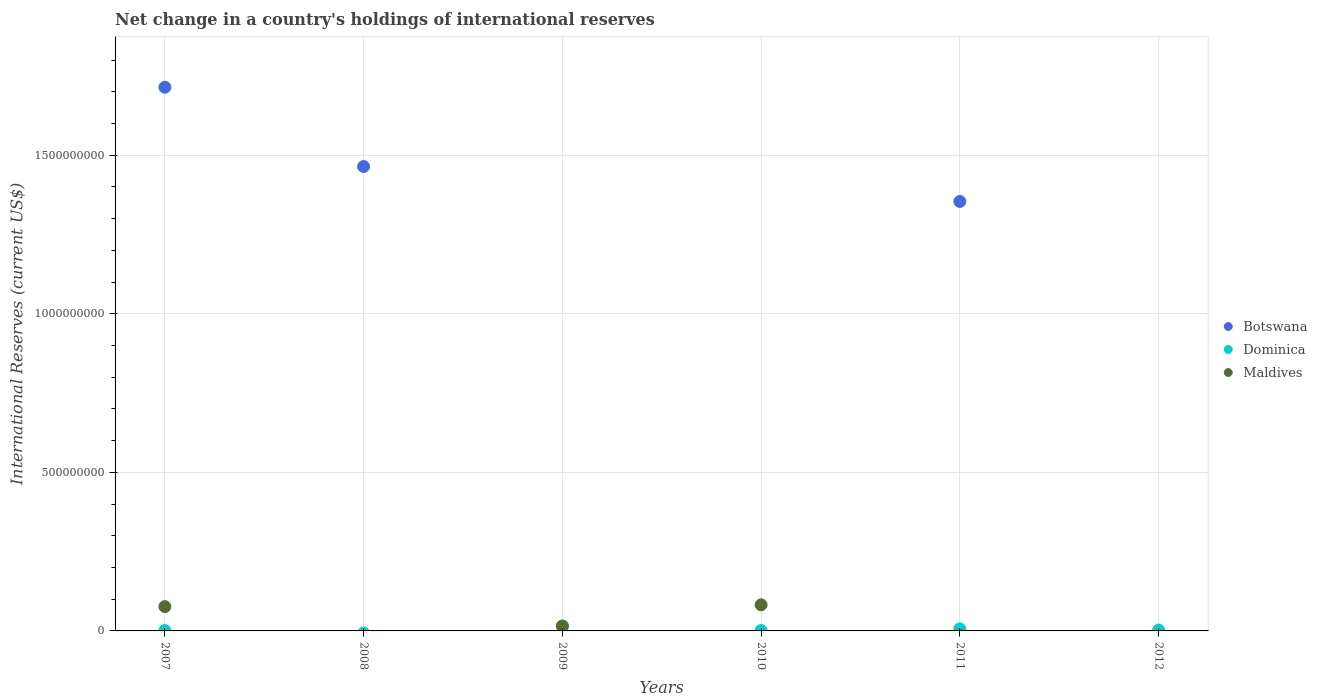How many different coloured dotlines are there?
Offer a very short reply. 3. Is the number of dotlines equal to the number of legend labels?
Give a very brief answer. No. Across all years, what is the maximum international reserves in Botswana?
Offer a very short reply. 1.71e+09. In which year was the international reserves in Botswana maximum?
Your answer should be compact. 2007. What is the total international reserves in Botswana in the graph?
Make the answer very short. 4.53e+09. What is the difference between the international reserves in Dominica in 2009 and that in 2012?
Offer a terse response. 1.26e+07. What is the difference between the international reserves in Dominica in 2007 and the international reserves in Botswana in 2009?
Your response must be concise. 1.16e+06. What is the average international reserves in Botswana per year?
Provide a succinct answer. 7.56e+08. In the year 2010, what is the difference between the international reserves in Dominica and international reserves in Maldives?
Ensure brevity in your answer.  -8.11e+07. What is the ratio of the international reserves in Dominica in 2010 to that in 2011?
Provide a short and direct response. 0.19. Is the international reserves in Botswana in 2007 less than that in 2008?
Provide a short and direct response. No. Is the difference between the international reserves in Dominica in 2009 and 2010 greater than the difference between the international reserves in Maldives in 2009 and 2010?
Provide a short and direct response. Yes. What is the difference between the highest and the second highest international reserves in Botswana?
Provide a short and direct response. 2.50e+08. What is the difference between the highest and the lowest international reserves in Maldives?
Provide a short and direct response. 8.23e+07. In how many years, is the international reserves in Maldives greater than the average international reserves in Maldives taken over all years?
Provide a short and direct response. 2. Is the sum of the international reserves in Dominica in 2007 and 2009 greater than the maximum international reserves in Maldives across all years?
Offer a terse response. No. Is the international reserves in Dominica strictly less than the international reserves in Maldives over the years?
Give a very brief answer. No. How many years are there in the graph?
Ensure brevity in your answer.  6. Does the graph contain grids?
Keep it short and to the point. Yes. How many legend labels are there?
Make the answer very short. 3. How are the legend labels stacked?
Make the answer very short. Vertical. What is the title of the graph?
Keep it short and to the point. Net change in a country's holdings of international reserves. What is the label or title of the X-axis?
Ensure brevity in your answer.  Years. What is the label or title of the Y-axis?
Your answer should be very brief. International Reserves (current US$). What is the International Reserves (current US$) of Botswana in 2007?
Provide a short and direct response. 1.71e+09. What is the International Reserves (current US$) of Dominica in 2007?
Provide a short and direct response. 1.16e+06. What is the International Reserves (current US$) of Maldives in 2007?
Offer a very short reply. 7.67e+07. What is the International Reserves (current US$) in Botswana in 2008?
Your answer should be very brief. 1.46e+09. What is the International Reserves (current US$) of Dominica in 2008?
Offer a terse response. 0. What is the International Reserves (current US$) in Maldives in 2008?
Your answer should be compact. 0. What is the International Reserves (current US$) of Dominica in 2009?
Give a very brief answer. 1.53e+07. What is the International Reserves (current US$) of Maldives in 2009?
Your answer should be very brief. 1.54e+07. What is the International Reserves (current US$) of Botswana in 2010?
Make the answer very short. 0. What is the International Reserves (current US$) in Dominica in 2010?
Give a very brief answer. 1.24e+06. What is the International Reserves (current US$) in Maldives in 2010?
Give a very brief answer. 8.23e+07. What is the International Reserves (current US$) of Botswana in 2011?
Your response must be concise. 1.35e+09. What is the International Reserves (current US$) in Dominica in 2011?
Provide a short and direct response. 6.48e+06. What is the International Reserves (current US$) in Botswana in 2012?
Your response must be concise. 0. What is the International Reserves (current US$) of Dominica in 2012?
Offer a very short reply. 2.73e+06. What is the International Reserves (current US$) in Maldives in 2012?
Provide a succinct answer. 0. Across all years, what is the maximum International Reserves (current US$) of Botswana?
Keep it short and to the point. 1.71e+09. Across all years, what is the maximum International Reserves (current US$) in Dominica?
Provide a short and direct response. 1.53e+07. Across all years, what is the maximum International Reserves (current US$) of Maldives?
Your answer should be very brief. 8.23e+07. Across all years, what is the minimum International Reserves (current US$) in Dominica?
Ensure brevity in your answer.  0. What is the total International Reserves (current US$) in Botswana in the graph?
Provide a short and direct response. 4.53e+09. What is the total International Reserves (current US$) in Dominica in the graph?
Provide a succinct answer. 2.69e+07. What is the total International Reserves (current US$) of Maldives in the graph?
Ensure brevity in your answer.  1.74e+08. What is the difference between the International Reserves (current US$) in Botswana in 2007 and that in 2008?
Your answer should be very brief. 2.50e+08. What is the difference between the International Reserves (current US$) in Dominica in 2007 and that in 2009?
Offer a very short reply. -1.42e+07. What is the difference between the International Reserves (current US$) in Maldives in 2007 and that in 2009?
Offer a terse response. 6.13e+07. What is the difference between the International Reserves (current US$) of Dominica in 2007 and that in 2010?
Provide a succinct answer. -7.75e+04. What is the difference between the International Reserves (current US$) of Maldives in 2007 and that in 2010?
Your response must be concise. -5.64e+06. What is the difference between the International Reserves (current US$) in Botswana in 2007 and that in 2011?
Your response must be concise. 3.60e+08. What is the difference between the International Reserves (current US$) in Dominica in 2007 and that in 2011?
Your answer should be very brief. -5.32e+06. What is the difference between the International Reserves (current US$) in Dominica in 2007 and that in 2012?
Ensure brevity in your answer.  -1.57e+06. What is the difference between the International Reserves (current US$) in Botswana in 2008 and that in 2011?
Your answer should be compact. 1.10e+08. What is the difference between the International Reserves (current US$) of Dominica in 2009 and that in 2010?
Give a very brief answer. 1.41e+07. What is the difference between the International Reserves (current US$) in Maldives in 2009 and that in 2010?
Provide a short and direct response. -6.70e+07. What is the difference between the International Reserves (current US$) of Dominica in 2009 and that in 2011?
Your answer should be very brief. 8.84e+06. What is the difference between the International Reserves (current US$) in Dominica in 2009 and that in 2012?
Give a very brief answer. 1.26e+07. What is the difference between the International Reserves (current US$) in Dominica in 2010 and that in 2011?
Make the answer very short. -5.24e+06. What is the difference between the International Reserves (current US$) in Dominica in 2010 and that in 2012?
Your response must be concise. -1.49e+06. What is the difference between the International Reserves (current US$) in Dominica in 2011 and that in 2012?
Offer a terse response. 3.75e+06. What is the difference between the International Reserves (current US$) of Botswana in 2007 and the International Reserves (current US$) of Dominica in 2009?
Give a very brief answer. 1.70e+09. What is the difference between the International Reserves (current US$) in Botswana in 2007 and the International Reserves (current US$) in Maldives in 2009?
Ensure brevity in your answer.  1.70e+09. What is the difference between the International Reserves (current US$) in Dominica in 2007 and the International Reserves (current US$) in Maldives in 2009?
Keep it short and to the point. -1.42e+07. What is the difference between the International Reserves (current US$) of Botswana in 2007 and the International Reserves (current US$) of Dominica in 2010?
Your answer should be very brief. 1.71e+09. What is the difference between the International Reserves (current US$) of Botswana in 2007 and the International Reserves (current US$) of Maldives in 2010?
Your response must be concise. 1.63e+09. What is the difference between the International Reserves (current US$) of Dominica in 2007 and the International Reserves (current US$) of Maldives in 2010?
Keep it short and to the point. -8.12e+07. What is the difference between the International Reserves (current US$) of Botswana in 2007 and the International Reserves (current US$) of Dominica in 2011?
Your answer should be compact. 1.71e+09. What is the difference between the International Reserves (current US$) of Botswana in 2007 and the International Reserves (current US$) of Dominica in 2012?
Make the answer very short. 1.71e+09. What is the difference between the International Reserves (current US$) in Botswana in 2008 and the International Reserves (current US$) in Dominica in 2009?
Your response must be concise. 1.45e+09. What is the difference between the International Reserves (current US$) in Botswana in 2008 and the International Reserves (current US$) in Maldives in 2009?
Your response must be concise. 1.45e+09. What is the difference between the International Reserves (current US$) in Botswana in 2008 and the International Reserves (current US$) in Dominica in 2010?
Your response must be concise. 1.46e+09. What is the difference between the International Reserves (current US$) in Botswana in 2008 and the International Reserves (current US$) in Maldives in 2010?
Your answer should be very brief. 1.38e+09. What is the difference between the International Reserves (current US$) of Botswana in 2008 and the International Reserves (current US$) of Dominica in 2011?
Give a very brief answer. 1.46e+09. What is the difference between the International Reserves (current US$) of Botswana in 2008 and the International Reserves (current US$) of Dominica in 2012?
Ensure brevity in your answer.  1.46e+09. What is the difference between the International Reserves (current US$) of Dominica in 2009 and the International Reserves (current US$) of Maldives in 2010?
Your answer should be very brief. -6.70e+07. What is the difference between the International Reserves (current US$) of Botswana in 2011 and the International Reserves (current US$) of Dominica in 2012?
Keep it short and to the point. 1.35e+09. What is the average International Reserves (current US$) of Botswana per year?
Offer a very short reply. 7.56e+08. What is the average International Reserves (current US$) in Dominica per year?
Keep it short and to the point. 4.49e+06. What is the average International Reserves (current US$) in Maldives per year?
Keep it short and to the point. 2.91e+07. In the year 2007, what is the difference between the International Reserves (current US$) of Botswana and International Reserves (current US$) of Dominica?
Your response must be concise. 1.71e+09. In the year 2007, what is the difference between the International Reserves (current US$) in Botswana and International Reserves (current US$) in Maldives?
Give a very brief answer. 1.64e+09. In the year 2007, what is the difference between the International Reserves (current US$) in Dominica and International Reserves (current US$) in Maldives?
Your answer should be compact. -7.55e+07. In the year 2009, what is the difference between the International Reserves (current US$) of Dominica and International Reserves (current US$) of Maldives?
Provide a succinct answer. -5.57e+04. In the year 2010, what is the difference between the International Reserves (current US$) of Dominica and International Reserves (current US$) of Maldives?
Provide a succinct answer. -8.11e+07. In the year 2011, what is the difference between the International Reserves (current US$) of Botswana and International Reserves (current US$) of Dominica?
Give a very brief answer. 1.35e+09. What is the ratio of the International Reserves (current US$) in Botswana in 2007 to that in 2008?
Your answer should be very brief. 1.17. What is the ratio of the International Reserves (current US$) in Dominica in 2007 to that in 2009?
Provide a succinct answer. 0.08. What is the ratio of the International Reserves (current US$) in Maldives in 2007 to that in 2009?
Your answer should be compact. 4.99. What is the ratio of the International Reserves (current US$) in Dominica in 2007 to that in 2010?
Make the answer very short. 0.94. What is the ratio of the International Reserves (current US$) in Maldives in 2007 to that in 2010?
Give a very brief answer. 0.93. What is the ratio of the International Reserves (current US$) in Botswana in 2007 to that in 2011?
Make the answer very short. 1.27. What is the ratio of the International Reserves (current US$) in Dominica in 2007 to that in 2011?
Provide a succinct answer. 0.18. What is the ratio of the International Reserves (current US$) of Dominica in 2007 to that in 2012?
Your answer should be very brief. 0.43. What is the ratio of the International Reserves (current US$) of Botswana in 2008 to that in 2011?
Your response must be concise. 1.08. What is the ratio of the International Reserves (current US$) of Dominica in 2009 to that in 2010?
Offer a terse response. 12.34. What is the ratio of the International Reserves (current US$) in Maldives in 2009 to that in 2010?
Give a very brief answer. 0.19. What is the ratio of the International Reserves (current US$) of Dominica in 2009 to that in 2011?
Make the answer very short. 2.36. What is the ratio of the International Reserves (current US$) of Dominica in 2009 to that in 2012?
Offer a terse response. 5.61. What is the ratio of the International Reserves (current US$) of Dominica in 2010 to that in 2011?
Give a very brief answer. 0.19. What is the ratio of the International Reserves (current US$) of Dominica in 2010 to that in 2012?
Your response must be concise. 0.45. What is the ratio of the International Reserves (current US$) in Dominica in 2011 to that in 2012?
Ensure brevity in your answer.  2.37. What is the difference between the highest and the second highest International Reserves (current US$) of Botswana?
Keep it short and to the point. 2.50e+08. What is the difference between the highest and the second highest International Reserves (current US$) in Dominica?
Provide a succinct answer. 8.84e+06. What is the difference between the highest and the second highest International Reserves (current US$) of Maldives?
Provide a succinct answer. 5.64e+06. What is the difference between the highest and the lowest International Reserves (current US$) in Botswana?
Ensure brevity in your answer.  1.71e+09. What is the difference between the highest and the lowest International Reserves (current US$) in Dominica?
Keep it short and to the point. 1.53e+07. What is the difference between the highest and the lowest International Reserves (current US$) of Maldives?
Offer a very short reply. 8.23e+07. 